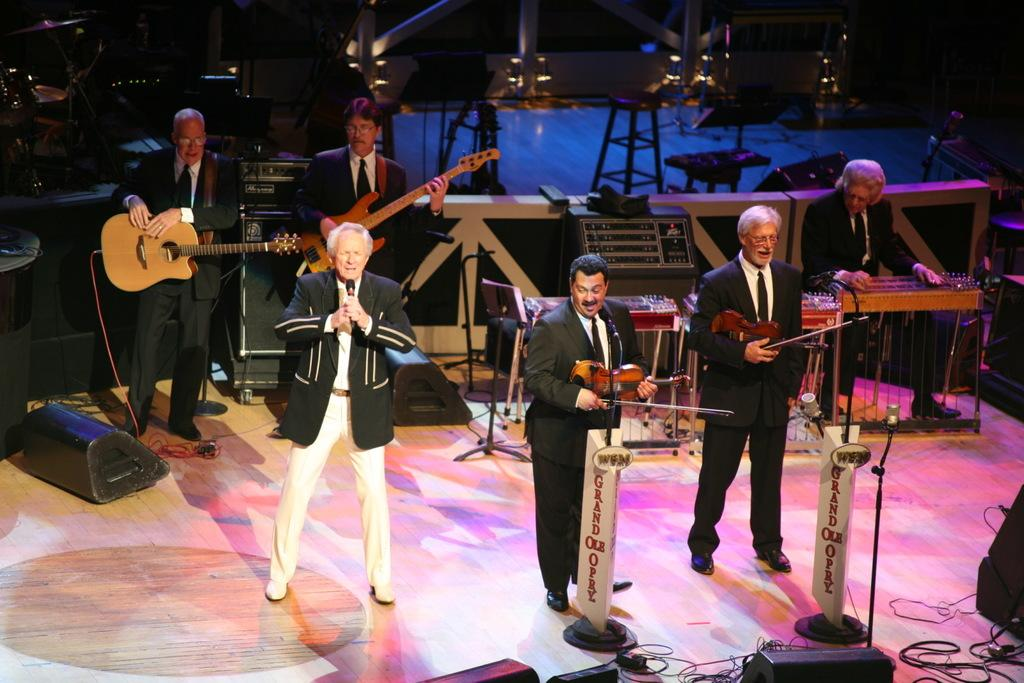How many people are performing in the image? There are six people in the image. What are the people doing on the stage? The people are performing on a stage, playing a guitar, and singing on a microphone. What organization is responsible for the hearing of the performance in the image? There is no mention of an organization or hearing in the image; it simply shows six people performing on a stage. 